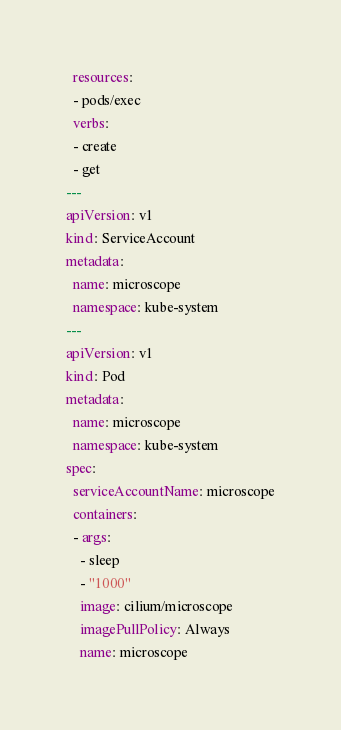<code> <loc_0><loc_0><loc_500><loc_500><_YAML_>  resources:
  - pods/exec
  verbs:
  - create
  - get
---
apiVersion: v1
kind: ServiceAccount
metadata:
  name: microscope
  namespace: kube-system
---
apiVersion: v1
kind: Pod
metadata:
  name: microscope
  namespace: kube-system
spec:
  serviceAccountName: microscope
  containers:
  - args:
    - sleep
    - "1000"
    image: cilium/microscope
    imagePullPolicy: Always
    name: microscope
</code> 